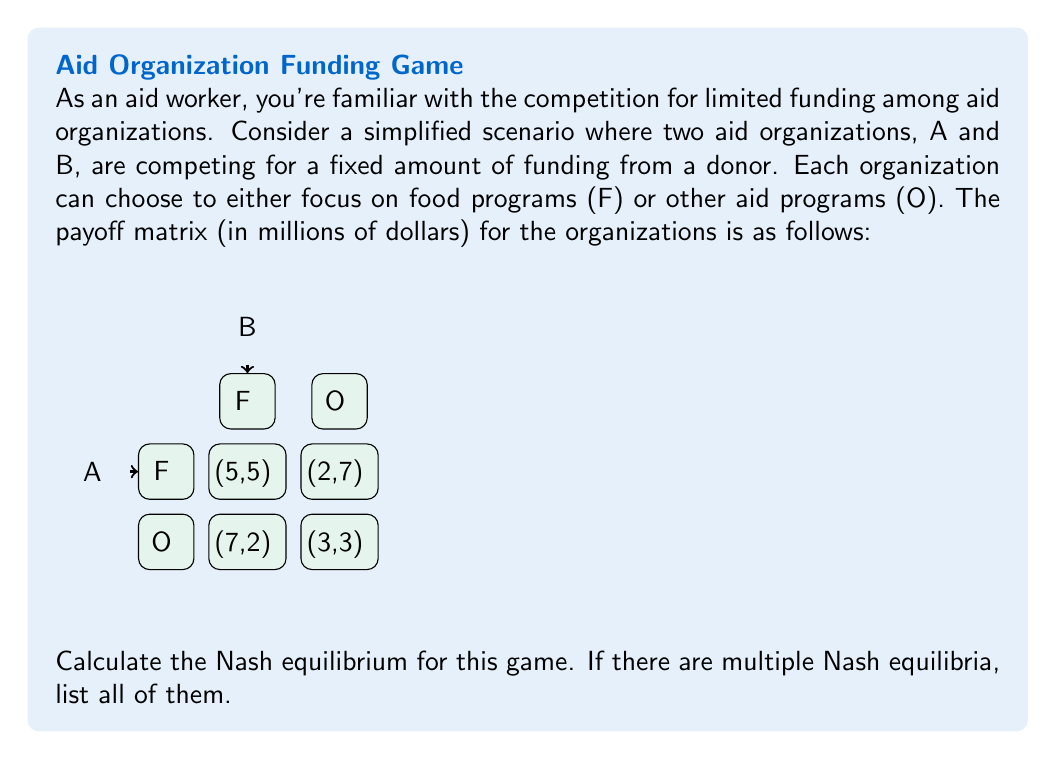Teach me how to tackle this problem. To find the Nash equilibrium, we need to identify the strategy profiles where neither player has an incentive to unilaterally deviate. Let's analyze this step-by-step:

1) First, let's check each strategy profile:

   (F, F): 
   - If A switches to O, it gets 7 instead of 5
   - If B switches to O, it gets 7 instead of 5
   This is not a Nash equilibrium.

   (F, O):
   - If A switches to O, it gets 3 instead of 2
   - If B switches to F, it gets 5 instead of 7
   This is not a Nash equilibrium.

   (O, F):
   - If A switches to F, it gets 5 instead of 7
   - If B switches to O, it gets 3 instead of 2
   This is not a Nash equilibrium.

   (O, O):
   - If A switches to F, it gets 2 instead of 3
   - If B switches to F, it gets 2 instead of 3
   This is a Nash equilibrium.

2) We can also solve this using the best response method:

   For A:
   - If B plays F, A's best response is O (7 > 5)
   - If B plays O, A's best response is O (3 > 2)

   For B:
   - If A plays F, B's best response is O (7 > 5)
   - If A plays O, B's best response is O (3 > 2)

3) The intersection of these best responses is (O, O), confirming our earlier finding.

Therefore, the unique Nash equilibrium for this game is (O, O), where both organizations choose to focus on other aid programs rather than food programs.
Answer: (O, O) 